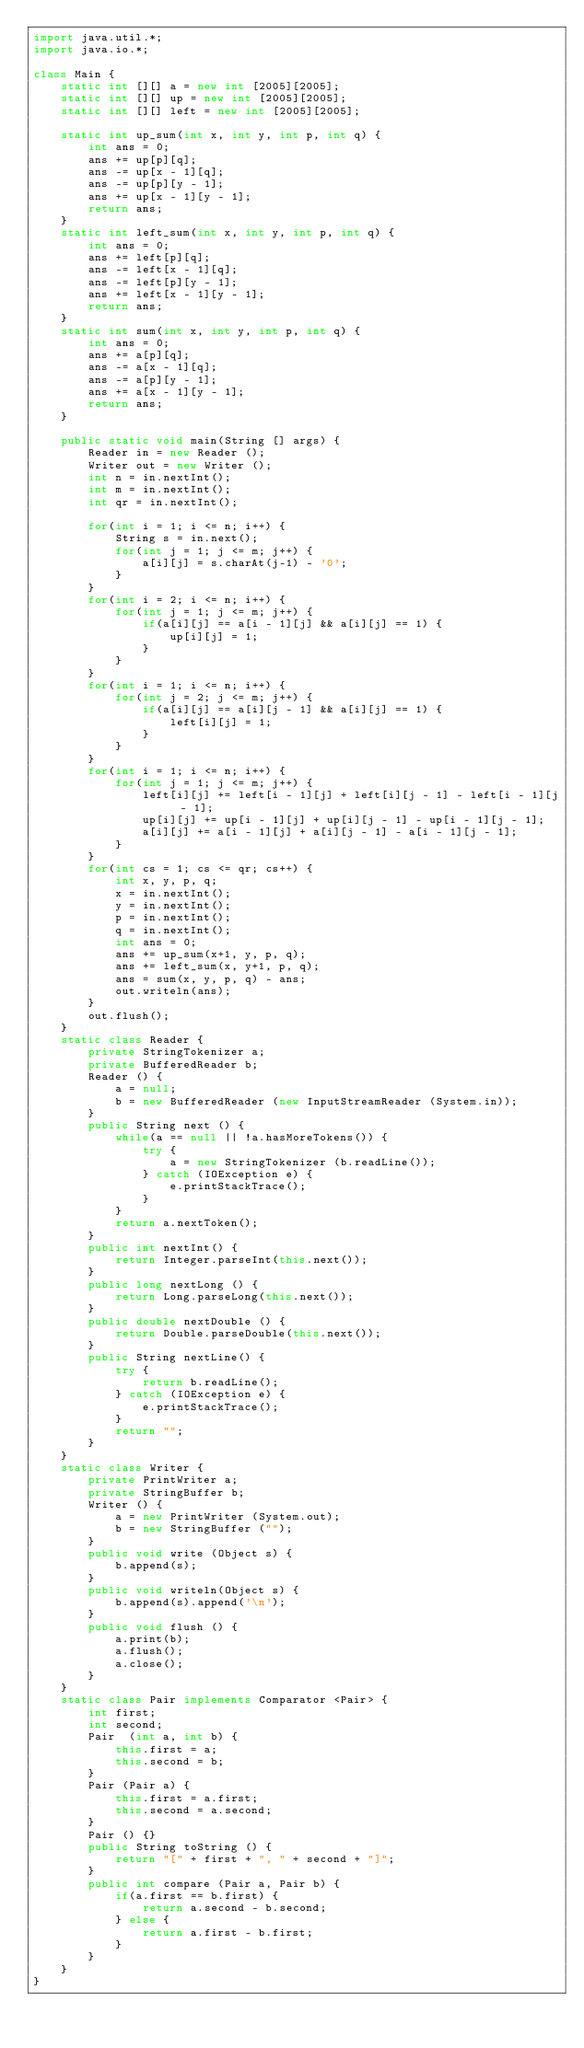Convert code to text. <code><loc_0><loc_0><loc_500><loc_500><_Java_>import java.util.*;
import java.io.*;

class Main {
    static int [][] a = new int [2005][2005];
    static int [][] up = new int [2005][2005];
    static int [][] left = new int [2005][2005];

    static int up_sum(int x, int y, int p, int q) {
        int ans = 0;
        ans += up[p][q];
        ans -= up[x - 1][q];
        ans -= up[p][y - 1];
        ans += up[x - 1][y - 1];
        return ans;
    }
    static int left_sum(int x, int y, int p, int q) {
        int ans = 0;
        ans += left[p][q];
        ans -= left[x - 1][q];
        ans -= left[p][y - 1];
        ans += left[x - 1][y - 1];
        return ans;
    }
    static int sum(int x, int y, int p, int q) {
        int ans = 0;
        ans += a[p][q];
        ans -= a[x - 1][q];
        ans -= a[p][y - 1];
        ans += a[x - 1][y - 1];
        return ans;
    }

    public static void main(String [] args) {
        Reader in = new Reader ();
        Writer out = new Writer ();
        int n = in.nextInt();
        int m = in.nextInt();
        int qr = in.nextInt();

        for(int i = 1; i <= n; i++) {
            String s = in.next();
            for(int j = 1; j <= m; j++) {
                a[i][j] = s.charAt(j-1) - '0';
            }
        }
        for(int i = 2; i <= n; i++) {
            for(int j = 1; j <= m; j++) {
                if(a[i][j] == a[i - 1][j] && a[i][j] == 1) {
                    up[i][j] = 1;
                }
            }
        }
        for(int i = 1; i <= n; i++) {
            for(int j = 2; j <= m; j++) {
                if(a[i][j] == a[i][j - 1] && a[i][j] == 1) {
                    left[i][j] = 1;
                }
            }
        }
        for(int i = 1; i <= n; i++) {
            for(int j = 1; j <= m; j++) {
                left[i][j] += left[i - 1][j] + left[i][j - 1] - left[i - 1][j - 1];
                up[i][j] += up[i - 1][j] + up[i][j - 1] - up[i - 1][j - 1];
                a[i][j] += a[i - 1][j] + a[i][j - 1] - a[i - 1][j - 1];            
            }
        }
        for(int cs = 1; cs <= qr; cs++) {
            int x, y, p, q;
            x = in.nextInt();
            y = in.nextInt();
            p = in.nextInt();
            q = in.nextInt();
            int ans = 0;
            ans += up_sum(x+1, y, p, q);
            ans += left_sum(x, y+1, p, q);
            ans = sum(x, y, p, q) - ans;
            out.writeln(ans);
        }
        out.flush();
    }
    static class Reader {
        private StringTokenizer a;
        private BufferedReader b;
        Reader () {
            a = null;
            b = new BufferedReader (new InputStreamReader (System.in));
        }
        public String next () {
            while(a == null || !a.hasMoreTokens()) {
                try {
                    a = new StringTokenizer (b.readLine());
                } catch (IOException e) {
                    e.printStackTrace();
                }
            }
            return a.nextToken();
        }
        public int nextInt() {
            return Integer.parseInt(this.next());
        }
        public long nextLong () {
            return Long.parseLong(this.next());
        }
        public double nextDouble () {
            return Double.parseDouble(this.next());
        }
        public String nextLine() {
            try {
                return b.readLine();
            } catch (IOException e) {
                e.printStackTrace();
            }
            return "";
        }
    }
    static class Writer {
        private PrintWriter a;
        private StringBuffer b;
        Writer () {
            a = new PrintWriter (System.out);
            b = new StringBuffer ("");
        }
        public void write (Object s) {
            b.append(s);
        }
        public void writeln(Object s) {
            b.append(s).append('\n');
        }
        public void flush () {
            a.print(b);
            a.flush();
            a.close();
        }
    }
    static class Pair implements Comparator <Pair> {
        int first;
        int second;
        Pair  (int a, int b) {
            this.first = a;
            this.second = b;
        }
        Pair (Pair a) {
            this.first = a.first;
            this.second = a.second;
        } 
        Pair () {}
        public String toString () {
            return "[" + first + ", " + second + "]";
        }
        public int compare (Pair a, Pair b) {
            if(a.first == b.first) {
                return a.second - b.second;
            } else {
                return a.first - b.first;
            }
        }
    } 
}</code> 